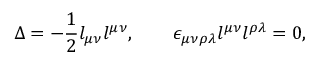Convert formula to latex. <formula><loc_0><loc_0><loc_500><loc_500>\Delta = - { \frac { 1 } { 2 } } l _ { \mu \nu } l ^ { \mu \nu } , \quad \epsilon _ { \mu \nu \rho \lambda } l ^ { \mu \nu } l ^ { \rho \lambda } = 0 ,</formula> 